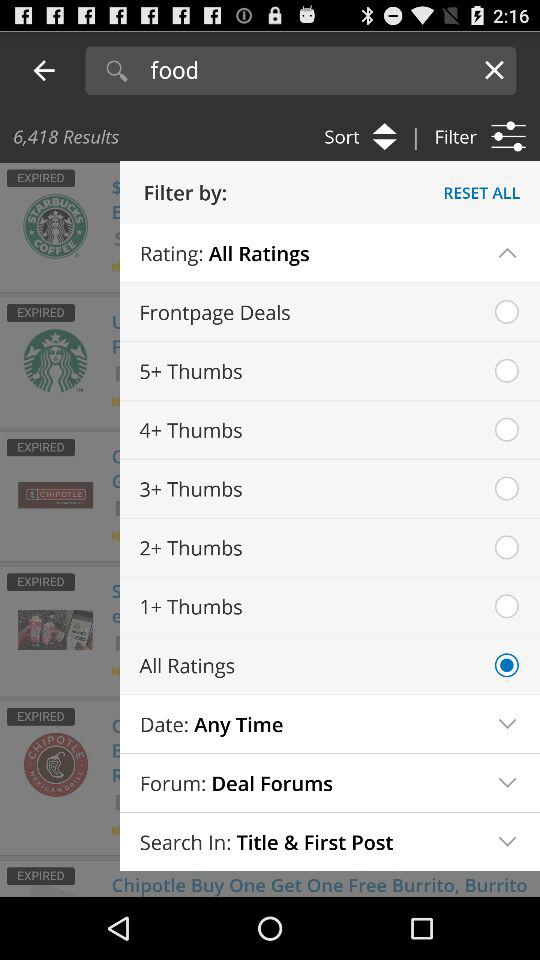Which option has been selected? The selected option is "All Ratings". 